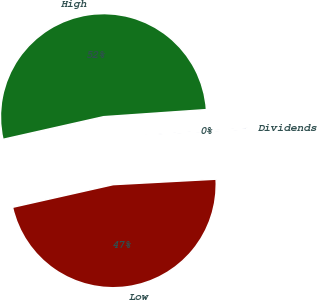Convert chart to OTSL. <chart><loc_0><loc_0><loc_500><loc_500><pie_chart><fcel>Dividends<fcel>High<fcel>Low<nl><fcel>0.25%<fcel>52.43%<fcel>47.32%<nl></chart> 